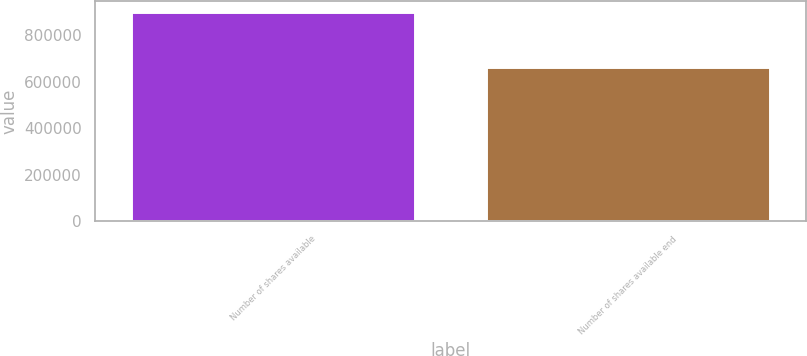<chart> <loc_0><loc_0><loc_500><loc_500><bar_chart><fcel>Number of shares available<fcel>Number of shares available end<nl><fcel>901195<fcel>663320<nl></chart> 